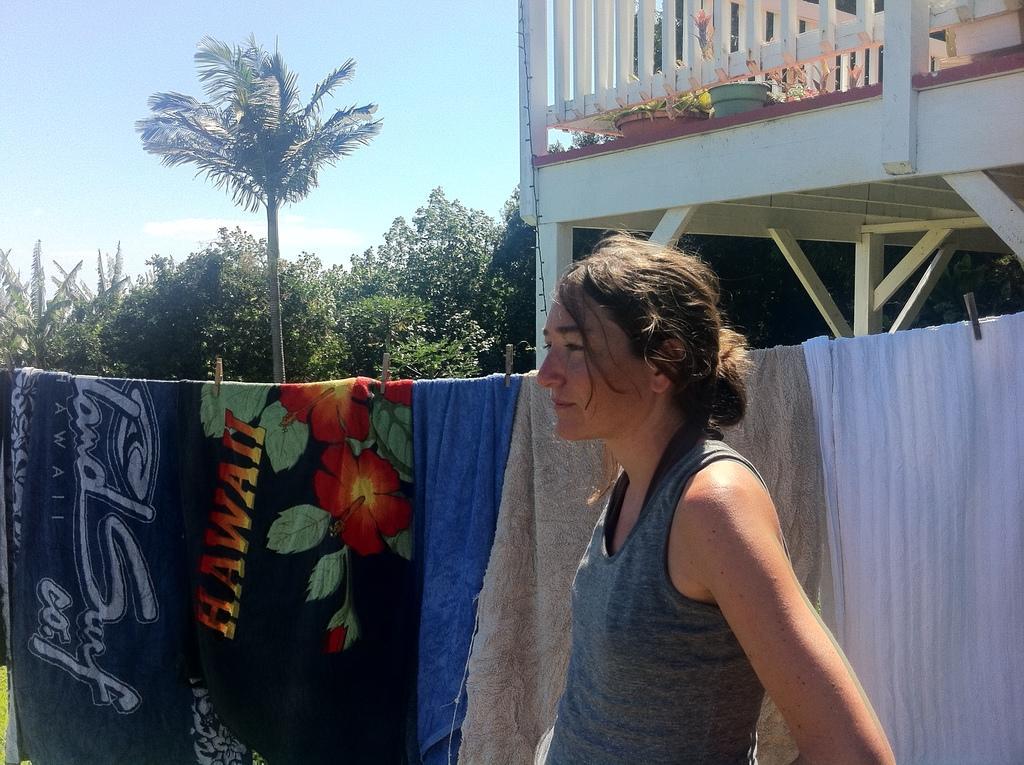In one or two sentences, can you explain what this image depicts? In this image, we can see a woman is standing. Background we can see clothespins, trees, wooden objects, plants, pots, railings and sky. 